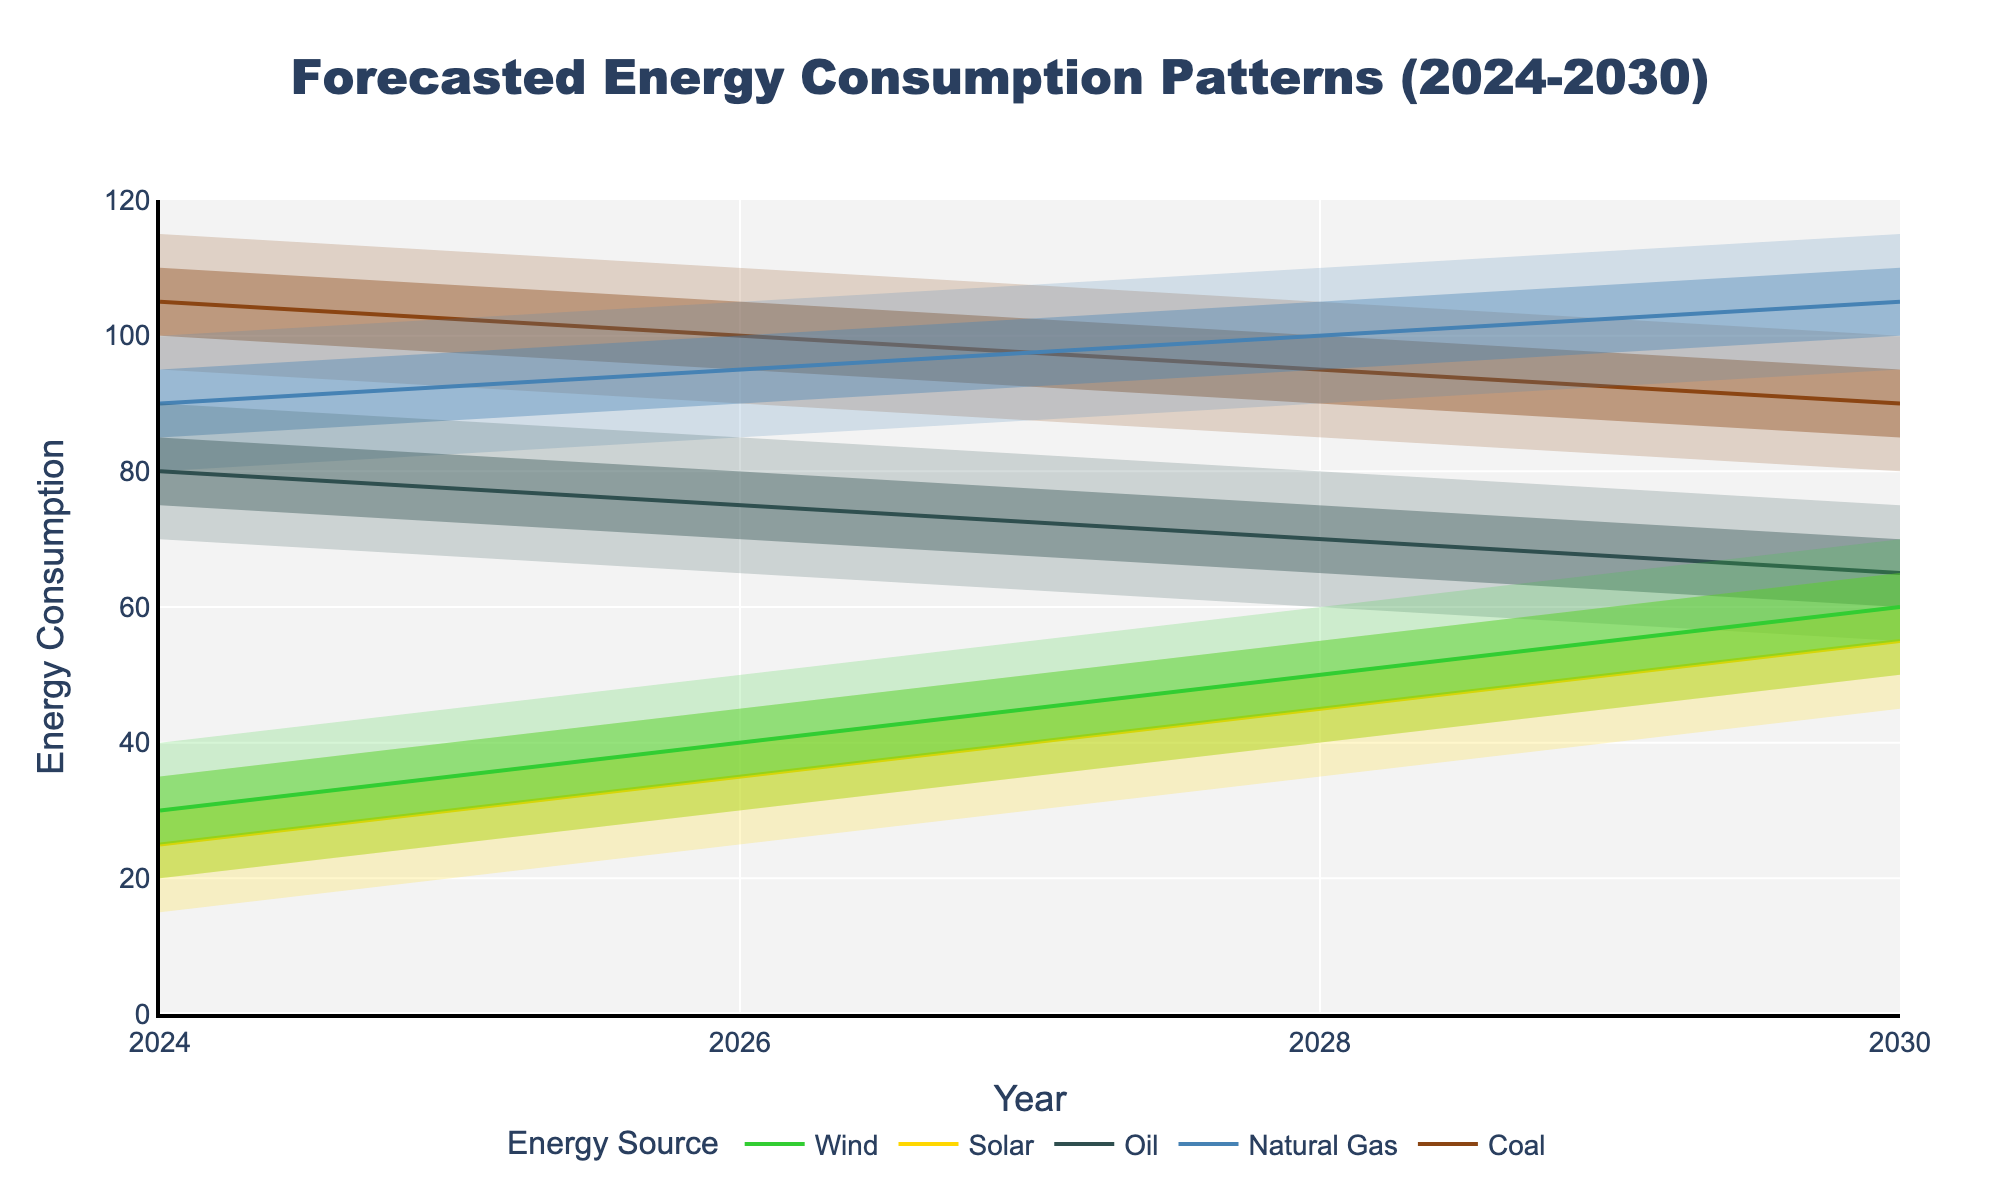What is the title of the figure? The title of the figure is typically located at the top and summarizes the chart's information. Here, it states "Forecasted Energy Consumption Patterns (2024-2030)."
Answer: Forecasted Energy Consumption Patterns (2024-2030) Which energy source is expected to have the highest median consumption in 2030? The median consumption for each energy source in 2030 is shown by the 'P50' line. Comparing them, Natural Gas has the highest median at 105.
Answer: Natural Gas Which renewable energy source is expected to see the most growth from 2024 to 2030 based on the median values? By observing the 'P50' values for Solar and Wind from 2024 to 2030, Solar increases from 25 to 55, while Wind increases from 30 to 60. The increase is more significant for Solar (30) than for Wind (25).
Answer: Solar Compare the P90 values of Coal and Wind in 2028. Which one is higher and by how much? In 2028, the P90 value for Coal is 105 and for Wind is 60. The difference is 105 - 60.
Answer: Coal by 45 How does the range of uncertainty (difference between P90 and P10) for Natural Gas change from 2024 to 2030? For 2024, the range is 100 - 80 = 20. For 2030, the range is 115 - 95 = 20. The range of uncertainty remains constant at 20.
Answer: Remains constant What is the forecasted median energy consumption for Oil in 2026, and how does it compare to Wind for the same year? The median for Oil in 2026 is 75 and for Wind is 40. Comparing these, Oil's median is 75 - 40 = 35 units higher than Wind's median.
Answer: 75 for Oil, 35 units higher Which energy source has the smallest forecasted range (difference between P90 and P10) in 2024, and what is that range? In 2024, the range for Coal is 115 - 95 = 20, Natural Gas is 100 - 80 = 20, Oil is 90 - 70 = 20, Solar is 35 - 15 = 20, and Wind is 40 - 20 = 20. All ranges are equal at 20.
Answer: All ranges are 20 